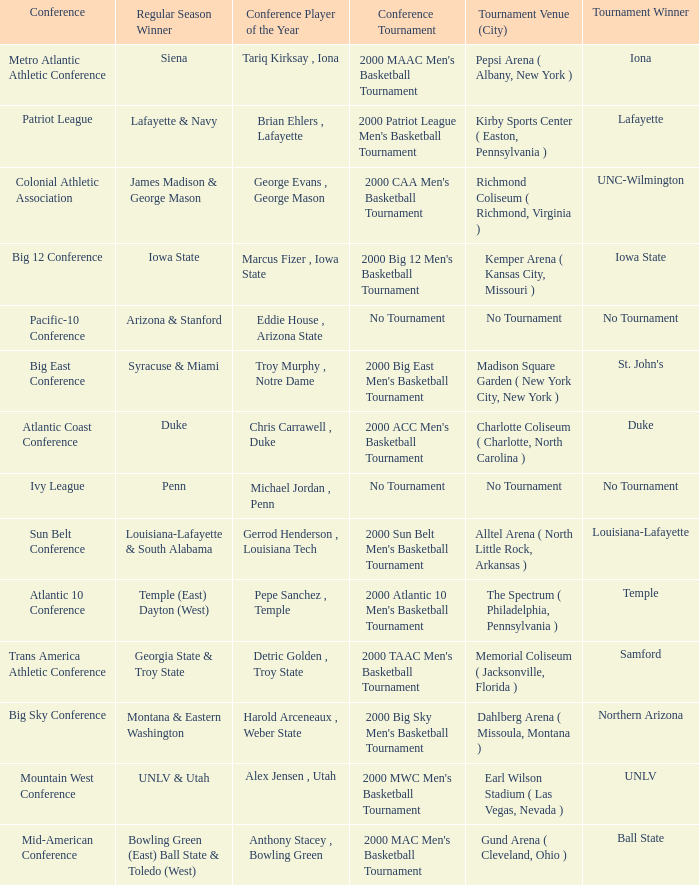How many players of the year are there in the Mountain West Conference? 1.0. 